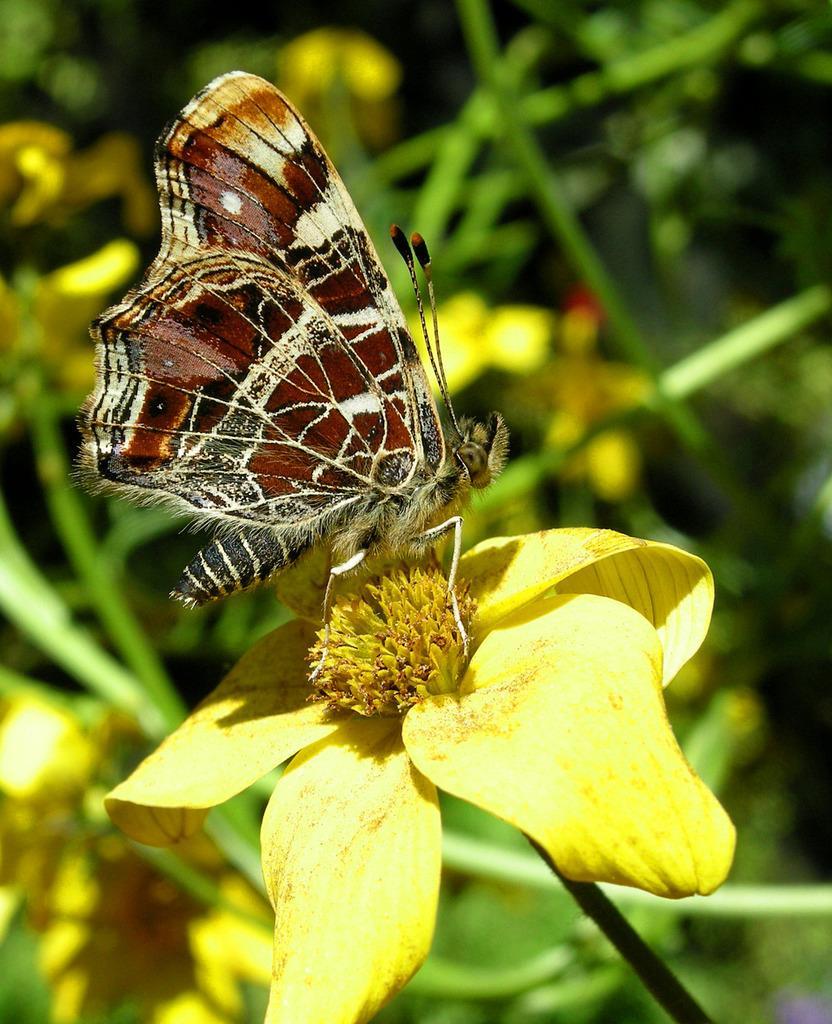Please provide a concise description of this image. In this picture I can see that there is a butterfly on the flower and there is a yellow color flower here. In the background I can see that some plants and there are some flowers. 